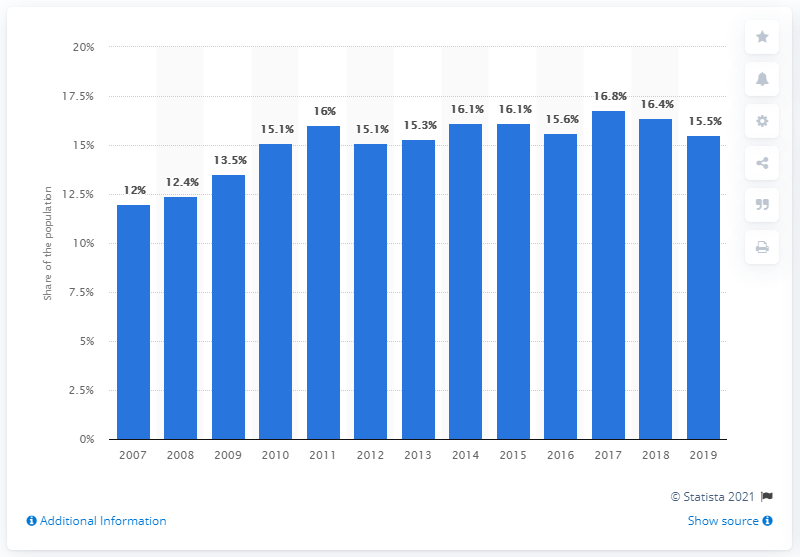Specify some key components in this picture. In 2017, the highest percentage of the population in the Netherlands with high blood pressure was 16.8%. 